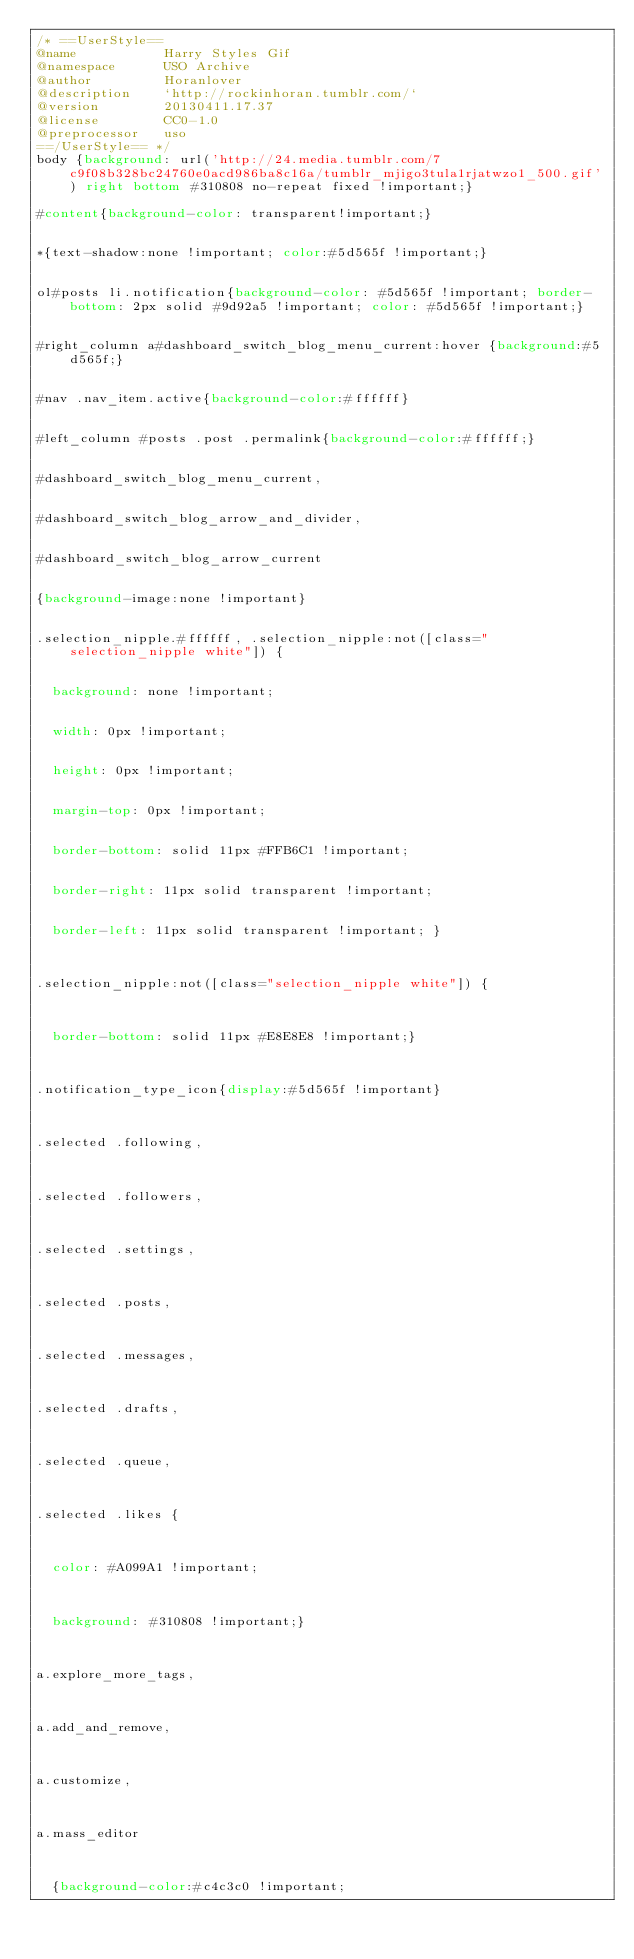Convert code to text. <code><loc_0><loc_0><loc_500><loc_500><_CSS_>/* ==UserStyle==
@name           Harry Styles Gif
@namespace      USO Archive
@author         Horanlover
@description    `http://rockinhoran.tumblr.com/`
@version        20130411.17.37
@license        CC0-1.0
@preprocessor   uso
==/UserStyle== */
body {background: url('http://24.media.tumblr.com/7c9f08b328bc24760e0acd986ba8c16a/tumblr_mjigo3tula1rjatwzo1_500.gif') right bottom #310808 no-repeat fixed !important;} 

#content{background-color: transparent!important;}


*{text-shadow:none !important; color:#5d565f !important;}


ol#posts li.notification{background-color: #5d565f !important; border-bottom: 2px solid #9d92a5 !important; color: #5d565f !important;}


#right_column a#dashboard_switch_blog_menu_current:hover {background:#5d565f;}


#nav .nav_item.active{background-color:#ffffff}


#left_column #posts .post .permalink{background-color:#ffffff;}


#dashboard_switch_blog_menu_current,


#dashboard_switch_blog_arrow_and_divider,


#dashboard_switch_blog_arrow_current


{background-image:none !important}


.selection_nipple.#ffffff, .selection_nipple:not([class="selection_nipple white"]) { 


	background: none !important;


	width: 0px !important;


	height: 0px !important;


	margin-top: 0px !important;


	border-bottom: solid 11px #FFB6C1 !important;


	border-right: 11px solid transparent !important;


	border-left: 11px solid transparent !important; }



.selection_nipple:not([class="selection_nipple white"]) {



	border-bottom: solid 11px #E8E8E8 !important;}



.notification_type_icon{display:#5d565f !important}



.selected .following,



.selected .followers,



.selected .settings,



.selected .posts,



.selected .messages,



.selected .drafts,



.selected .queue, 



.selected .likes {



	color: #A099A1 !important; 



	background: #310808 !important;}



a.explore_more_tags,



a.add_and_remove,



a.customize,



a.mass_editor



	{background-color:#c4c3c0 !important;  


</code> 